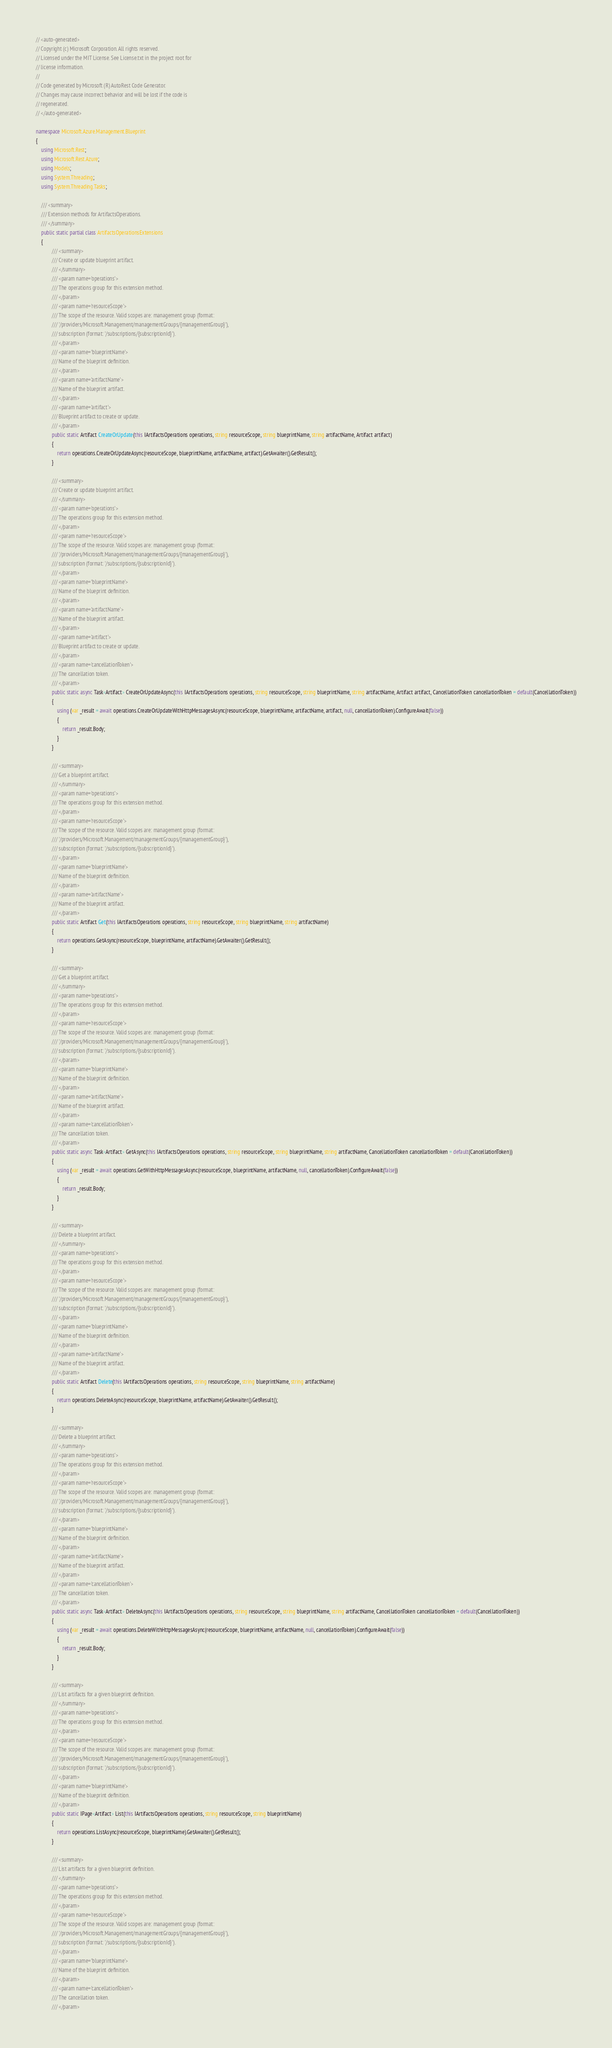Convert code to text. <code><loc_0><loc_0><loc_500><loc_500><_C#_>// <auto-generated>
// Copyright (c) Microsoft Corporation. All rights reserved.
// Licensed under the MIT License. See License.txt in the project root for
// license information.
//
// Code generated by Microsoft (R) AutoRest Code Generator.
// Changes may cause incorrect behavior and will be lost if the code is
// regenerated.
// </auto-generated>

namespace Microsoft.Azure.Management.Blueprint
{
    using Microsoft.Rest;
    using Microsoft.Rest.Azure;
    using Models;
    using System.Threading;
    using System.Threading.Tasks;

    /// <summary>
    /// Extension methods for ArtifactsOperations.
    /// </summary>
    public static partial class ArtifactsOperationsExtensions
    {
            /// <summary>
            /// Create or update blueprint artifact.
            /// </summary>
            /// <param name='operations'>
            /// The operations group for this extension method.
            /// </param>
            /// <param name='resourceScope'>
            /// The scope of the resource. Valid scopes are: management group (format:
            /// '/providers/Microsoft.Management/managementGroups/{managementGroup}'),
            /// subscription (format: '/subscriptions/{subscriptionId}').
            /// </param>
            /// <param name='blueprintName'>
            /// Name of the blueprint definition.
            /// </param>
            /// <param name='artifactName'>
            /// Name of the blueprint artifact.
            /// </param>
            /// <param name='artifact'>
            /// Blueprint artifact to create or update.
            /// </param>
            public static Artifact CreateOrUpdate(this IArtifactsOperations operations, string resourceScope, string blueprintName, string artifactName, Artifact artifact)
            {
                return operations.CreateOrUpdateAsync(resourceScope, blueprintName, artifactName, artifact).GetAwaiter().GetResult();
            }

            /// <summary>
            /// Create or update blueprint artifact.
            /// </summary>
            /// <param name='operations'>
            /// The operations group for this extension method.
            /// </param>
            /// <param name='resourceScope'>
            /// The scope of the resource. Valid scopes are: management group (format:
            /// '/providers/Microsoft.Management/managementGroups/{managementGroup}'),
            /// subscription (format: '/subscriptions/{subscriptionId}').
            /// </param>
            /// <param name='blueprintName'>
            /// Name of the blueprint definition.
            /// </param>
            /// <param name='artifactName'>
            /// Name of the blueprint artifact.
            /// </param>
            /// <param name='artifact'>
            /// Blueprint artifact to create or update.
            /// </param>
            /// <param name='cancellationToken'>
            /// The cancellation token.
            /// </param>
            public static async Task<Artifact> CreateOrUpdateAsync(this IArtifactsOperations operations, string resourceScope, string blueprintName, string artifactName, Artifact artifact, CancellationToken cancellationToken = default(CancellationToken))
            {
                using (var _result = await operations.CreateOrUpdateWithHttpMessagesAsync(resourceScope, blueprintName, artifactName, artifact, null, cancellationToken).ConfigureAwait(false))
                {
                    return _result.Body;
                }
            }

            /// <summary>
            /// Get a blueprint artifact.
            /// </summary>
            /// <param name='operations'>
            /// The operations group for this extension method.
            /// </param>
            /// <param name='resourceScope'>
            /// The scope of the resource. Valid scopes are: management group (format:
            /// '/providers/Microsoft.Management/managementGroups/{managementGroup}'),
            /// subscription (format: '/subscriptions/{subscriptionId}').
            /// </param>
            /// <param name='blueprintName'>
            /// Name of the blueprint definition.
            /// </param>
            /// <param name='artifactName'>
            /// Name of the blueprint artifact.
            /// </param>
            public static Artifact Get(this IArtifactsOperations operations, string resourceScope, string blueprintName, string artifactName)
            {
                return operations.GetAsync(resourceScope, blueprintName, artifactName).GetAwaiter().GetResult();
            }

            /// <summary>
            /// Get a blueprint artifact.
            /// </summary>
            /// <param name='operations'>
            /// The operations group for this extension method.
            /// </param>
            /// <param name='resourceScope'>
            /// The scope of the resource. Valid scopes are: management group (format:
            /// '/providers/Microsoft.Management/managementGroups/{managementGroup}'),
            /// subscription (format: '/subscriptions/{subscriptionId}').
            /// </param>
            /// <param name='blueprintName'>
            /// Name of the blueprint definition.
            /// </param>
            /// <param name='artifactName'>
            /// Name of the blueprint artifact.
            /// </param>
            /// <param name='cancellationToken'>
            /// The cancellation token.
            /// </param>
            public static async Task<Artifact> GetAsync(this IArtifactsOperations operations, string resourceScope, string blueprintName, string artifactName, CancellationToken cancellationToken = default(CancellationToken))
            {
                using (var _result = await operations.GetWithHttpMessagesAsync(resourceScope, blueprintName, artifactName, null, cancellationToken).ConfigureAwait(false))
                {
                    return _result.Body;
                }
            }

            /// <summary>
            /// Delete a blueprint artifact.
            /// </summary>
            /// <param name='operations'>
            /// The operations group for this extension method.
            /// </param>
            /// <param name='resourceScope'>
            /// The scope of the resource. Valid scopes are: management group (format:
            /// '/providers/Microsoft.Management/managementGroups/{managementGroup}'),
            /// subscription (format: '/subscriptions/{subscriptionId}').
            /// </param>
            /// <param name='blueprintName'>
            /// Name of the blueprint definition.
            /// </param>
            /// <param name='artifactName'>
            /// Name of the blueprint artifact.
            /// </param>
            public static Artifact Delete(this IArtifactsOperations operations, string resourceScope, string blueprintName, string artifactName)
            {
                return operations.DeleteAsync(resourceScope, blueprintName, artifactName).GetAwaiter().GetResult();
            }

            /// <summary>
            /// Delete a blueprint artifact.
            /// </summary>
            /// <param name='operations'>
            /// The operations group for this extension method.
            /// </param>
            /// <param name='resourceScope'>
            /// The scope of the resource. Valid scopes are: management group (format:
            /// '/providers/Microsoft.Management/managementGroups/{managementGroup}'),
            /// subscription (format: '/subscriptions/{subscriptionId}').
            /// </param>
            /// <param name='blueprintName'>
            /// Name of the blueprint definition.
            /// </param>
            /// <param name='artifactName'>
            /// Name of the blueprint artifact.
            /// </param>
            /// <param name='cancellationToken'>
            /// The cancellation token.
            /// </param>
            public static async Task<Artifact> DeleteAsync(this IArtifactsOperations operations, string resourceScope, string blueprintName, string artifactName, CancellationToken cancellationToken = default(CancellationToken))
            {
                using (var _result = await operations.DeleteWithHttpMessagesAsync(resourceScope, blueprintName, artifactName, null, cancellationToken).ConfigureAwait(false))
                {
                    return _result.Body;
                }
            }

            /// <summary>
            /// List artifacts for a given blueprint definition.
            /// </summary>
            /// <param name='operations'>
            /// The operations group for this extension method.
            /// </param>
            /// <param name='resourceScope'>
            /// The scope of the resource. Valid scopes are: management group (format:
            /// '/providers/Microsoft.Management/managementGroups/{managementGroup}'),
            /// subscription (format: '/subscriptions/{subscriptionId}').
            /// </param>
            /// <param name='blueprintName'>
            /// Name of the blueprint definition.
            /// </param>
            public static IPage<Artifact> List(this IArtifactsOperations operations, string resourceScope, string blueprintName)
            {
                return operations.ListAsync(resourceScope, blueprintName).GetAwaiter().GetResult();
            }

            /// <summary>
            /// List artifacts for a given blueprint definition.
            /// </summary>
            /// <param name='operations'>
            /// The operations group for this extension method.
            /// </param>
            /// <param name='resourceScope'>
            /// The scope of the resource. Valid scopes are: management group (format:
            /// '/providers/Microsoft.Management/managementGroups/{managementGroup}'),
            /// subscription (format: '/subscriptions/{subscriptionId}').
            /// </param>
            /// <param name='blueprintName'>
            /// Name of the blueprint definition.
            /// </param>
            /// <param name='cancellationToken'>
            /// The cancellation token.
            /// </param></code> 